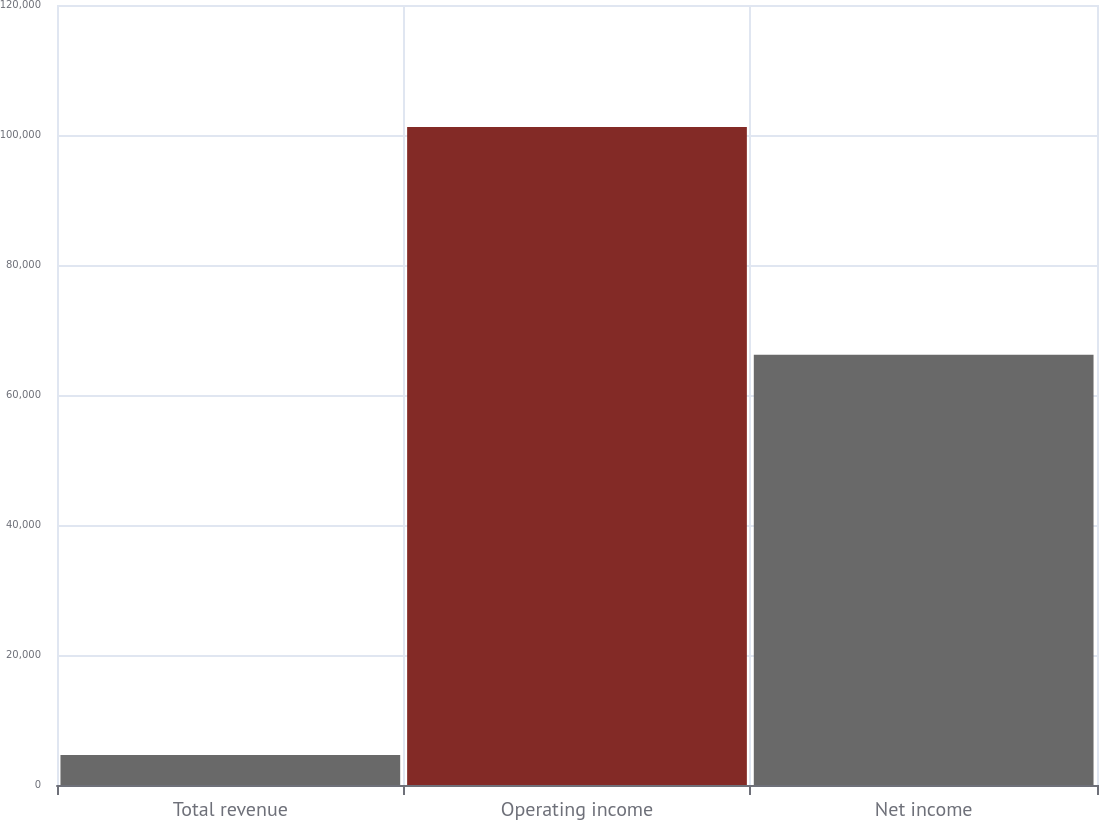<chart> <loc_0><loc_0><loc_500><loc_500><bar_chart><fcel>Total revenue<fcel>Operating income<fcel>Net income<nl><fcel>4632<fcel>101232<fcel>66197<nl></chart> 